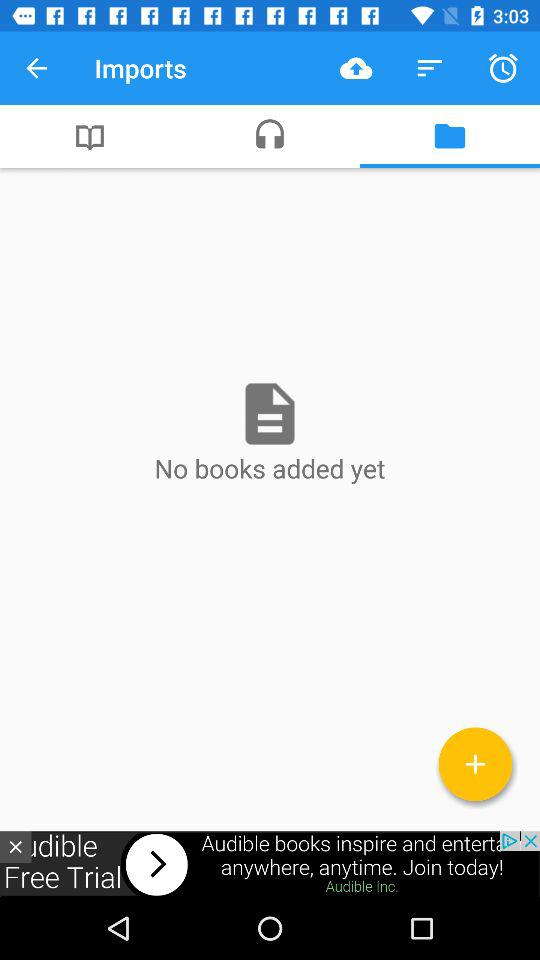How many books were added? There were no books added. 